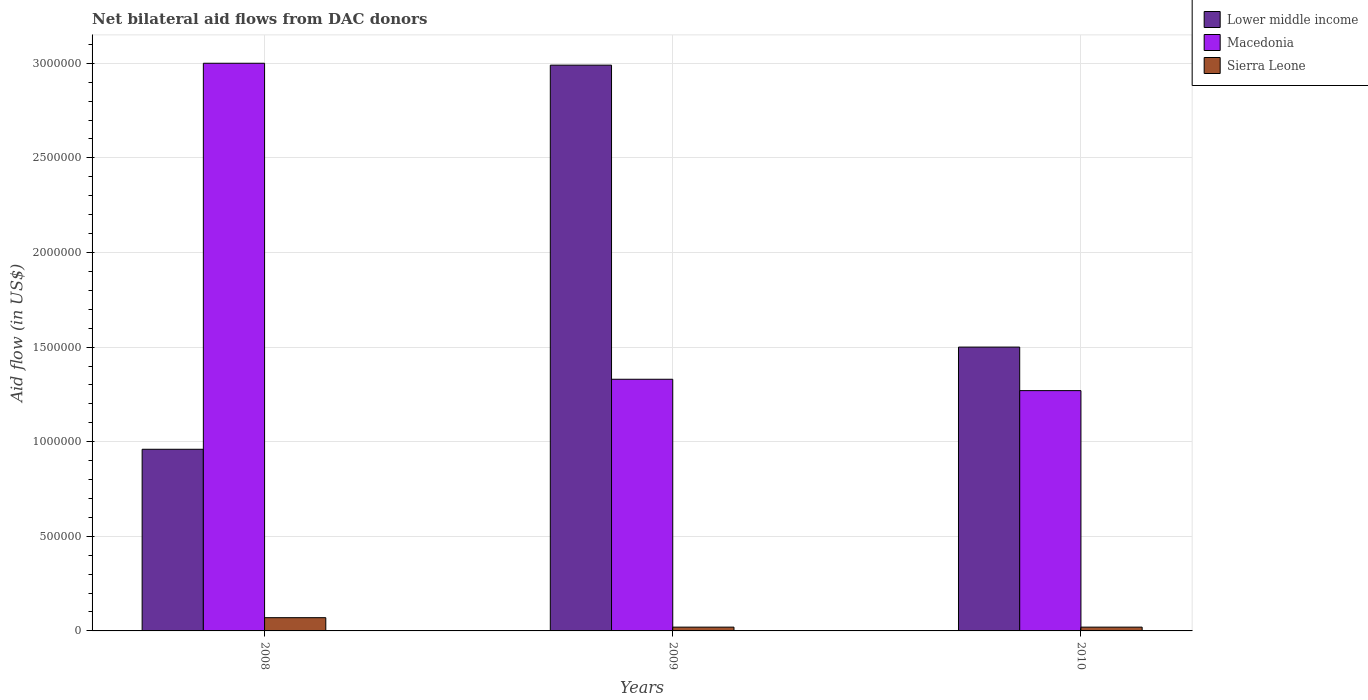How many different coloured bars are there?
Provide a succinct answer. 3. Are the number of bars per tick equal to the number of legend labels?
Ensure brevity in your answer.  Yes. What is the label of the 1st group of bars from the left?
Give a very brief answer. 2008. Across all years, what is the maximum net bilateral aid flow in Macedonia?
Provide a succinct answer. 3.00e+06. Across all years, what is the minimum net bilateral aid flow in Lower middle income?
Make the answer very short. 9.60e+05. In which year was the net bilateral aid flow in Lower middle income minimum?
Your response must be concise. 2008. What is the total net bilateral aid flow in Macedonia in the graph?
Make the answer very short. 5.60e+06. What is the difference between the net bilateral aid flow in Macedonia in 2009 and that in 2010?
Give a very brief answer. 6.00e+04. What is the difference between the net bilateral aid flow in Macedonia in 2008 and the net bilateral aid flow in Sierra Leone in 2010?
Keep it short and to the point. 2.98e+06. What is the average net bilateral aid flow in Sierra Leone per year?
Offer a terse response. 3.67e+04. In the year 2009, what is the difference between the net bilateral aid flow in Lower middle income and net bilateral aid flow in Sierra Leone?
Keep it short and to the point. 2.97e+06. In how many years, is the net bilateral aid flow in Macedonia greater than 2900000 US$?
Your answer should be very brief. 1. What is the difference between the highest and the second highest net bilateral aid flow in Macedonia?
Your response must be concise. 1.67e+06. What is the difference between the highest and the lowest net bilateral aid flow in Macedonia?
Give a very brief answer. 1.73e+06. In how many years, is the net bilateral aid flow in Sierra Leone greater than the average net bilateral aid flow in Sierra Leone taken over all years?
Your response must be concise. 1. Is the sum of the net bilateral aid flow in Sierra Leone in 2008 and 2010 greater than the maximum net bilateral aid flow in Lower middle income across all years?
Ensure brevity in your answer.  No. What does the 1st bar from the left in 2009 represents?
Your response must be concise. Lower middle income. What does the 2nd bar from the right in 2010 represents?
Give a very brief answer. Macedonia. Is it the case that in every year, the sum of the net bilateral aid flow in Macedonia and net bilateral aid flow in Lower middle income is greater than the net bilateral aid flow in Sierra Leone?
Make the answer very short. Yes. How many bars are there?
Ensure brevity in your answer.  9. Are all the bars in the graph horizontal?
Offer a terse response. No. What is the difference between two consecutive major ticks on the Y-axis?
Offer a very short reply. 5.00e+05. Are the values on the major ticks of Y-axis written in scientific E-notation?
Offer a very short reply. No. Does the graph contain any zero values?
Keep it short and to the point. No. How are the legend labels stacked?
Give a very brief answer. Vertical. What is the title of the graph?
Provide a short and direct response. Net bilateral aid flows from DAC donors. Does "Fiji" appear as one of the legend labels in the graph?
Give a very brief answer. No. What is the label or title of the Y-axis?
Keep it short and to the point. Aid flow (in US$). What is the Aid flow (in US$) of Lower middle income in 2008?
Offer a very short reply. 9.60e+05. What is the Aid flow (in US$) in Macedonia in 2008?
Keep it short and to the point. 3.00e+06. What is the Aid flow (in US$) of Lower middle income in 2009?
Make the answer very short. 2.99e+06. What is the Aid flow (in US$) of Macedonia in 2009?
Give a very brief answer. 1.33e+06. What is the Aid flow (in US$) of Lower middle income in 2010?
Your response must be concise. 1.50e+06. What is the Aid flow (in US$) of Macedonia in 2010?
Your answer should be compact. 1.27e+06. Across all years, what is the maximum Aid flow (in US$) of Lower middle income?
Keep it short and to the point. 2.99e+06. Across all years, what is the maximum Aid flow (in US$) in Macedonia?
Your response must be concise. 3.00e+06. Across all years, what is the maximum Aid flow (in US$) of Sierra Leone?
Provide a short and direct response. 7.00e+04. Across all years, what is the minimum Aid flow (in US$) in Lower middle income?
Your answer should be very brief. 9.60e+05. Across all years, what is the minimum Aid flow (in US$) in Macedonia?
Provide a succinct answer. 1.27e+06. Across all years, what is the minimum Aid flow (in US$) in Sierra Leone?
Make the answer very short. 2.00e+04. What is the total Aid flow (in US$) in Lower middle income in the graph?
Your answer should be compact. 5.45e+06. What is the total Aid flow (in US$) of Macedonia in the graph?
Offer a terse response. 5.60e+06. What is the total Aid flow (in US$) of Sierra Leone in the graph?
Make the answer very short. 1.10e+05. What is the difference between the Aid flow (in US$) in Lower middle income in 2008 and that in 2009?
Offer a terse response. -2.03e+06. What is the difference between the Aid flow (in US$) of Macedonia in 2008 and that in 2009?
Offer a terse response. 1.67e+06. What is the difference between the Aid flow (in US$) of Lower middle income in 2008 and that in 2010?
Make the answer very short. -5.40e+05. What is the difference between the Aid flow (in US$) of Macedonia in 2008 and that in 2010?
Keep it short and to the point. 1.73e+06. What is the difference between the Aid flow (in US$) of Lower middle income in 2009 and that in 2010?
Keep it short and to the point. 1.49e+06. What is the difference between the Aid flow (in US$) of Lower middle income in 2008 and the Aid flow (in US$) of Macedonia in 2009?
Provide a succinct answer. -3.70e+05. What is the difference between the Aid flow (in US$) in Lower middle income in 2008 and the Aid flow (in US$) in Sierra Leone in 2009?
Give a very brief answer. 9.40e+05. What is the difference between the Aid flow (in US$) of Macedonia in 2008 and the Aid flow (in US$) of Sierra Leone in 2009?
Offer a very short reply. 2.98e+06. What is the difference between the Aid flow (in US$) of Lower middle income in 2008 and the Aid flow (in US$) of Macedonia in 2010?
Your response must be concise. -3.10e+05. What is the difference between the Aid flow (in US$) of Lower middle income in 2008 and the Aid flow (in US$) of Sierra Leone in 2010?
Ensure brevity in your answer.  9.40e+05. What is the difference between the Aid flow (in US$) of Macedonia in 2008 and the Aid flow (in US$) of Sierra Leone in 2010?
Give a very brief answer. 2.98e+06. What is the difference between the Aid flow (in US$) in Lower middle income in 2009 and the Aid flow (in US$) in Macedonia in 2010?
Your response must be concise. 1.72e+06. What is the difference between the Aid flow (in US$) of Lower middle income in 2009 and the Aid flow (in US$) of Sierra Leone in 2010?
Offer a terse response. 2.97e+06. What is the difference between the Aid flow (in US$) in Macedonia in 2009 and the Aid flow (in US$) in Sierra Leone in 2010?
Provide a succinct answer. 1.31e+06. What is the average Aid flow (in US$) in Lower middle income per year?
Your answer should be compact. 1.82e+06. What is the average Aid flow (in US$) in Macedonia per year?
Ensure brevity in your answer.  1.87e+06. What is the average Aid flow (in US$) of Sierra Leone per year?
Keep it short and to the point. 3.67e+04. In the year 2008, what is the difference between the Aid flow (in US$) of Lower middle income and Aid flow (in US$) of Macedonia?
Offer a very short reply. -2.04e+06. In the year 2008, what is the difference between the Aid flow (in US$) of Lower middle income and Aid flow (in US$) of Sierra Leone?
Offer a very short reply. 8.90e+05. In the year 2008, what is the difference between the Aid flow (in US$) of Macedonia and Aid flow (in US$) of Sierra Leone?
Offer a very short reply. 2.93e+06. In the year 2009, what is the difference between the Aid flow (in US$) in Lower middle income and Aid flow (in US$) in Macedonia?
Give a very brief answer. 1.66e+06. In the year 2009, what is the difference between the Aid flow (in US$) in Lower middle income and Aid flow (in US$) in Sierra Leone?
Your response must be concise. 2.97e+06. In the year 2009, what is the difference between the Aid flow (in US$) of Macedonia and Aid flow (in US$) of Sierra Leone?
Ensure brevity in your answer.  1.31e+06. In the year 2010, what is the difference between the Aid flow (in US$) in Lower middle income and Aid flow (in US$) in Macedonia?
Your answer should be compact. 2.30e+05. In the year 2010, what is the difference between the Aid flow (in US$) of Lower middle income and Aid flow (in US$) of Sierra Leone?
Your answer should be very brief. 1.48e+06. In the year 2010, what is the difference between the Aid flow (in US$) in Macedonia and Aid flow (in US$) in Sierra Leone?
Provide a short and direct response. 1.25e+06. What is the ratio of the Aid flow (in US$) of Lower middle income in 2008 to that in 2009?
Keep it short and to the point. 0.32. What is the ratio of the Aid flow (in US$) of Macedonia in 2008 to that in 2009?
Offer a very short reply. 2.26. What is the ratio of the Aid flow (in US$) in Sierra Leone in 2008 to that in 2009?
Give a very brief answer. 3.5. What is the ratio of the Aid flow (in US$) in Lower middle income in 2008 to that in 2010?
Provide a short and direct response. 0.64. What is the ratio of the Aid flow (in US$) of Macedonia in 2008 to that in 2010?
Provide a short and direct response. 2.36. What is the ratio of the Aid flow (in US$) in Sierra Leone in 2008 to that in 2010?
Provide a short and direct response. 3.5. What is the ratio of the Aid flow (in US$) of Lower middle income in 2009 to that in 2010?
Make the answer very short. 1.99. What is the ratio of the Aid flow (in US$) of Macedonia in 2009 to that in 2010?
Keep it short and to the point. 1.05. What is the difference between the highest and the second highest Aid flow (in US$) of Lower middle income?
Your answer should be compact. 1.49e+06. What is the difference between the highest and the second highest Aid flow (in US$) in Macedonia?
Offer a very short reply. 1.67e+06. What is the difference between the highest and the second highest Aid flow (in US$) in Sierra Leone?
Keep it short and to the point. 5.00e+04. What is the difference between the highest and the lowest Aid flow (in US$) in Lower middle income?
Offer a terse response. 2.03e+06. What is the difference between the highest and the lowest Aid flow (in US$) in Macedonia?
Keep it short and to the point. 1.73e+06. 